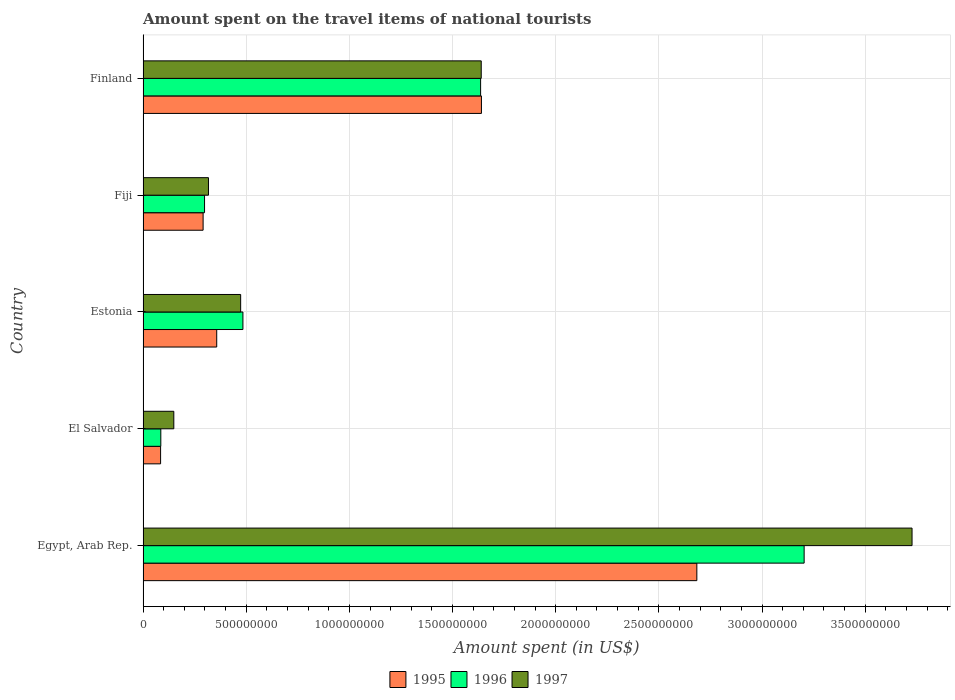How many different coloured bars are there?
Offer a very short reply. 3. How many groups of bars are there?
Offer a terse response. 5. Are the number of bars per tick equal to the number of legend labels?
Keep it short and to the point. Yes. Are the number of bars on each tick of the Y-axis equal?
Ensure brevity in your answer.  Yes. How many bars are there on the 3rd tick from the bottom?
Offer a very short reply. 3. What is the amount spent on the travel items of national tourists in 1997 in Estonia?
Your response must be concise. 4.73e+08. Across all countries, what is the maximum amount spent on the travel items of national tourists in 1995?
Your answer should be compact. 2.68e+09. Across all countries, what is the minimum amount spent on the travel items of national tourists in 1995?
Your answer should be very brief. 8.50e+07. In which country was the amount spent on the travel items of national tourists in 1995 maximum?
Provide a short and direct response. Egypt, Arab Rep. In which country was the amount spent on the travel items of national tourists in 1997 minimum?
Provide a short and direct response. El Salvador. What is the total amount spent on the travel items of national tourists in 1996 in the graph?
Your response must be concise. 5.71e+09. What is the difference between the amount spent on the travel items of national tourists in 1997 in El Salvador and that in Estonia?
Your answer should be compact. -3.24e+08. What is the difference between the amount spent on the travel items of national tourists in 1997 in El Salvador and the amount spent on the travel items of national tourists in 1995 in Estonia?
Offer a terse response. -2.08e+08. What is the average amount spent on the travel items of national tourists in 1995 per country?
Keep it short and to the point. 1.01e+09. What is the difference between the amount spent on the travel items of national tourists in 1996 and amount spent on the travel items of national tourists in 1997 in Estonia?
Make the answer very short. 1.10e+07. In how many countries, is the amount spent on the travel items of national tourists in 1996 greater than 3800000000 US$?
Give a very brief answer. 0. What is the ratio of the amount spent on the travel items of national tourists in 1997 in El Salvador to that in Finland?
Make the answer very short. 0.09. Is the difference between the amount spent on the travel items of national tourists in 1996 in El Salvador and Finland greater than the difference between the amount spent on the travel items of national tourists in 1997 in El Salvador and Finland?
Your answer should be compact. No. What is the difference between the highest and the second highest amount spent on the travel items of national tourists in 1995?
Your answer should be very brief. 1.04e+09. What is the difference between the highest and the lowest amount spent on the travel items of national tourists in 1995?
Your answer should be very brief. 2.60e+09. In how many countries, is the amount spent on the travel items of national tourists in 1997 greater than the average amount spent on the travel items of national tourists in 1997 taken over all countries?
Offer a terse response. 2. Is the sum of the amount spent on the travel items of national tourists in 1996 in El Salvador and Finland greater than the maximum amount spent on the travel items of national tourists in 1997 across all countries?
Keep it short and to the point. No. What does the 1st bar from the top in Estonia represents?
Your response must be concise. 1997. Is it the case that in every country, the sum of the amount spent on the travel items of national tourists in 1996 and amount spent on the travel items of national tourists in 1995 is greater than the amount spent on the travel items of national tourists in 1997?
Offer a terse response. Yes. How many bars are there?
Provide a short and direct response. 15. Are all the bars in the graph horizontal?
Your answer should be compact. Yes. How many countries are there in the graph?
Your response must be concise. 5. What is the difference between two consecutive major ticks on the X-axis?
Your answer should be compact. 5.00e+08. Are the values on the major ticks of X-axis written in scientific E-notation?
Your response must be concise. No. Does the graph contain any zero values?
Your response must be concise. No. How many legend labels are there?
Offer a very short reply. 3. What is the title of the graph?
Your answer should be very brief. Amount spent on the travel items of national tourists. Does "1975" appear as one of the legend labels in the graph?
Your answer should be compact. No. What is the label or title of the X-axis?
Offer a very short reply. Amount spent (in US$). What is the Amount spent (in US$) of 1995 in Egypt, Arab Rep.?
Provide a succinct answer. 2.68e+09. What is the Amount spent (in US$) of 1996 in Egypt, Arab Rep.?
Your answer should be very brief. 3.20e+09. What is the Amount spent (in US$) in 1997 in Egypt, Arab Rep.?
Your answer should be compact. 3.73e+09. What is the Amount spent (in US$) in 1995 in El Salvador?
Provide a short and direct response. 8.50e+07. What is the Amount spent (in US$) of 1996 in El Salvador?
Provide a short and direct response. 8.60e+07. What is the Amount spent (in US$) in 1997 in El Salvador?
Offer a terse response. 1.49e+08. What is the Amount spent (in US$) in 1995 in Estonia?
Give a very brief answer. 3.57e+08. What is the Amount spent (in US$) of 1996 in Estonia?
Keep it short and to the point. 4.84e+08. What is the Amount spent (in US$) in 1997 in Estonia?
Your answer should be very brief. 4.73e+08. What is the Amount spent (in US$) of 1995 in Fiji?
Your answer should be very brief. 2.91e+08. What is the Amount spent (in US$) of 1996 in Fiji?
Keep it short and to the point. 2.98e+08. What is the Amount spent (in US$) of 1997 in Fiji?
Your answer should be compact. 3.17e+08. What is the Amount spent (in US$) of 1995 in Finland?
Your response must be concise. 1.64e+09. What is the Amount spent (in US$) in 1996 in Finland?
Give a very brief answer. 1.64e+09. What is the Amount spent (in US$) of 1997 in Finland?
Provide a short and direct response. 1.64e+09. Across all countries, what is the maximum Amount spent (in US$) in 1995?
Your answer should be very brief. 2.68e+09. Across all countries, what is the maximum Amount spent (in US$) of 1996?
Offer a terse response. 3.20e+09. Across all countries, what is the maximum Amount spent (in US$) in 1997?
Offer a terse response. 3.73e+09. Across all countries, what is the minimum Amount spent (in US$) of 1995?
Provide a succinct answer. 8.50e+07. Across all countries, what is the minimum Amount spent (in US$) of 1996?
Ensure brevity in your answer.  8.60e+07. Across all countries, what is the minimum Amount spent (in US$) of 1997?
Your answer should be compact. 1.49e+08. What is the total Amount spent (in US$) in 1995 in the graph?
Ensure brevity in your answer.  5.06e+09. What is the total Amount spent (in US$) in 1996 in the graph?
Offer a very short reply. 5.71e+09. What is the total Amount spent (in US$) in 1997 in the graph?
Offer a very short reply. 6.30e+09. What is the difference between the Amount spent (in US$) of 1995 in Egypt, Arab Rep. and that in El Salvador?
Give a very brief answer. 2.60e+09. What is the difference between the Amount spent (in US$) of 1996 in Egypt, Arab Rep. and that in El Salvador?
Offer a very short reply. 3.12e+09. What is the difference between the Amount spent (in US$) in 1997 in Egypt, Arab Rep. and that in El Salvador?
Your answer should be compact. 3.58e+09. What is the difference between the Amount spent (in US$) of 1995 in Egypt, Arab Rep. and that in Estonia?
Your answer should be compact. 2.33e+09. What is the difference between the Amount spent (in US$) of 1996 in Egypt, Arab Rep. and that in Estonia?
Your answer should be compact. 2.72e+09. What is the difference between the Amount spent (in US$) of 1997 in Egypt, Arab Rep. and that in Estonia?
Offer a very short reply. 3.25e+09. What is the difference between the Amount spent (in US$) of 1995 in Egypt, Arab Rep. and that in Fiji?
Offer a terse response. 2.39e+09. What is the difference between the Amount spent (in US$) in 1996 in Egypt, Arab Rep. and that in Fiji?
Provide a short and direct response. 2.91e+09. What is the difference between the Amount spent (in US$) in 1997 in Egypt, Arab Rep. and that in Fiji?
Provide a short and direct response. 3.41e+09. What is the difference between the Amount spent (in US$) of 1995 in Egypt, Arab Rep. and that in Finland?
Offer a very short reply. 1.04e+09. What is the difference between the Amount spent (in US$) of 1996 in Egypt, Arab Rep. and that in Finland?
Keep it short and to the point. 1.57e+09. What is the difference between the Amount spent (in US$) of 1997 in Egypt, Arab Rep. and that in Finland?
Your answer should be very brief. 2.09e+09. What is the difference between the Amount spent (in US$) in 1995 in El Salvador and that in Estonia?
Ensure brevity in your answer.  -2.72e+08. What is the difference between the Amount spent (in US$) of 1996 in El Salvador and that in Estonia?
Offer a terse response. -3.98e+08. What is the difference between the Amount spent (in US$) of 1997 in El Salvador and that in Estonia?
Give a very brief answer. -3.24e+08. What is the difference between the Amount spent (in US$) in 1995 in El Salvador and that in Fiji?
Your response must be concise. -2.06e+08. What is the difference between the Amount spent (in US$) in 1996 in El Salvador and that in Fiji?
Your answer should be compact. -2.12e+08. What is the difference between the Amount spent (in US$) in 1997 in El Salvador and that in Fiji?
Ensure brevity in your answer.  -1.68e+08. What is the difference between the Amount spent (in US$) of 1995 in El Salvador and that in Finland?
Ensure brevity in your answer.  -1.56e+09. What is the difference between the Amount spent (in US$) of 1996 in El Salvador and that in Finland?
Provide a succinct answer. -1.55e+09. What is the difference between the Amount spent (in US$) in 1997 in El Salvador and that in Finland?
Give a very brief answer. -1.49e+09. What is the difference between the Amount spent (in US$) in 1995 in Estonia and that in Fiji?
Ensure brevity in your answer.  6.60e+07. What is the difference between the Amount spent (in US$) of 1996 in Estonia and that in Fiji?
Provide a succinct answer. 1.86e+08. What is the difference between the Amount spent (in US$) in 1997 in Estonia and that in Fiji?
Your answer should be compact. 1.56e+08. What is the difference between the Amount spent (in US$) in 1995 in Estonia and that in Finland?
Ensure brevity in your answer.  -1.28e+09. What is the difference between the Amount spent (in US$) in 1996 in Estonia and that in Finland?
Provide a short and direct response. -1.15e+09. What is the difference between the Amount spent (in US$) in 1997 in Estonia and that in Finland?
Provide a short and direct response. -1.17e+09. What is the difference between the Amount spent (in US$) of 1995 in Fiji and that in Finland?
Your response must be concise. -1.35e+09. What is the difference between the Amount spent (in US$) of 1996 in Fiji and that in Finland?
Your response must be concise. -1.34e+09. What is the difference between the Amount spent (in US$) in 1997 in Fiji and that in Finland?
Keep it short and to the point. -1.32e+09. What is the difference between the Amount spent (in US$) in 1995 in Egypt, Arab Rep. and the Amount spent (in US$) in 1996 in El Salvador?
Keep it short and to the point. 2.60e+09. What is the difference between the Amount spent (in US$) in 1995 in Egypt, Arab Rep. and the Amount spent (in US$) in 1997 in El Salvador?
Ensure brevity in your answer.  2.54e+09. What is the difference between the Amount spent (in US$) of 1996 in Egypt, Arab Rep. and the Amount spent (in US$) of 1997 in El Salvador?
Provide a succinct answer. 3.06e+09. What is the difference between the Amount spent (in US$) in 1995 in Egypt, Arab Rep. and the Amount spent (in US$) in 1996 in Estonia?
Provide a succinct answer. 2.20e+09. What is the difference between the Amount spent (in US$) in 1995 in Egypt, Arab Rep. and the Amount spent (in US$) in 1997 in Estonia?
Your response must be concise. 2.21e+09. What is the difference between the Amount spent (in US$) in 1996 in Egypt, Arab Rep. and the Amount spent (in US$) in 1997 in Estonia?
Provide a succinct answer. 2.73e+09. What is the difference between the Amount spent (in US$) of 1995 in Egypt, Arab Rep. and the Amount spent (in US$) of 1996 in Fiji?
Ensure brevity in your answer.  2.39e+09. What is the difference between the Amount spent (in US$) of 1995 in Egypt, Arab Rep. and the Amount spent (in US$) of 1997 in Fiji?
Offer a terse response. 2.37e+09. What is the difference between the Amount spent (in US$) in 1996 in Egypt, Arab Rep. and the Amount spent (in US$) in 1997 in Fiji?
Your response must be concise. 2.89e+09. What is the difference between the Amount spent (in US$) in 1995 in Egypt, Arab Rep. and the Amount spent (in US$) in 1996 in Finland?
Your answer should be compact. 1.05e+09. What is the difference between the Amount spent (in US$) in 1995 in Egypt, Arab Rep. and the Amount spent (in US$) in 1997 in Finland?
Ensure brevity in your answer.  1.04e+09. What is the difference between the Amount spent (in US$) of 1996 in Egypt, Arab Rep. and the Amount spent (in US$) of 1997 in Finland?
Offer a very short reply. 1.56e+09. What is the difference between the Amount spent (in US$) of 1995 in El Salvador and the Amount spent (in US$) of 1996 in Estonia?
Offer a very short reply. -3.99e+08. What is the difference between the Amount spent (in US$) in 1995 in El Salvador and the Amount spent (in US$) in 1997 in Estonia?
Your answer should be very brief. -3.88e+08. What is the difference between the Amount spent (in US$) of 1996 in El Salvador and the Amount spent (in US$) of 1997 in Estonia?
Provide a succinct answer. -3.87e+08. What is the difference between the Amount spent (in US$) of 1995 in El Salvador and the Amount spent (in US$) of 1996 in Fiji?
Give a very brief answer. -2.13e+08. What is the difference between the Amount spent (in US$) of 1995 in El Salvador and the Amount spent (in US$) of 1997 in Fiji?
Give a very brief answer. -2.32e+08. What is the difference between the Amount spent (in US$) of 1996 in El Salvador and the Amount spent (in US$) of 1997 in Fiji?
Provide a succinct answer. -2.31e+08. What is the difference between the Amount spent (in US$) in 1995 in El Salvador and the Amount spent (in US$) in 1996 in Finland?
Offer a terse response. -1.55e+09. What is the difference between the Amount spent (in US$) in 1995 in El Salvador and the Amount spent (in US$) in 1997 in Finland?
Offer a terse response. -1.55e+09. What is the difference between the Amount spent (in US$) of 1996 in El Salvador and the Amount spent (in US$) of 1997 in Finland?
Your response must be concise. -1.55e+09. What is the difference between the Amount spent (in US$) of 1995 in Estonia and the Amount spent (in US$) of 1996 in Fiji?
Your answer should be very brief. 5.90e+07. What is the difference between the Amount spent (in US$) in 1995 in Estonia and the Amount spent (in US$) in 1997 in Fiji?
Provide a short and direct response. 4.00e+07. What is the difference between the Amount spent (in US$) of 1996 in Estonia and the Amount spent (in US$) of 1997 in Fiji?
Your answer should be very brief. 1.67e+08. What is the difference between the Amount spent (in US$) in 1995 in Estonia and the Amount spent (in US$) in 1996 in Finland?
Provide a short and direct response. -1.28e+09. What is the difference between the Amount spent (in US$) of 1995 in Estonia and the Amount spent (in US$) of 1997 in Finland?
Provide a short and direct response. -1.28e+09. What is the difference between the Amount spent (in US$) in 1996 in Estonia and the Amount spent (in US$) in 1997 in Finland?
Ensure brevity in your answer.  -1.16e+09. What is the difference between the Amount spent (in US$) in 1995 in Fiji and the Amount spent (in US$) in 1996 in Finland?
Ensure brevity in your answer.  -1.34e+09. What is the difference between the Amount spent (in US$) in 1995 in Fiji and the Amount spent (in US$) in 1997 in Finland?
Give a very brief answer. -1.35e+09. What is the difference between the Amount spent (in US$) of 1996 in Fiji and the Amount spent (in US$) of 1997 in Finland?
Make the answer very short. -1.34e+09. What is the average Amount spent (in US$) of 1995 per country?
Provide a succinct answer. 1.01e+09. What is the average Amount spent (in US$) in 1996 per country?
Your response must be concise. 1.14e+09. What is the average Amount spent (in US$) of 1997 per country?
Your response must be concise. 1.26e+09. What is the difference between the Amount spent (in US$) in 1995 and Amount spent (in US$) in 1996 in Egypt, Arab Rep.?
Your answer should be very brief. -5.20e+08. What is the difference between the Amount spent (in US$) of 1995 and Amount spent (in US$) of 1997 in Egypt, Arab Rep.?
Keep it short and to the point. -1.04e+09. What is the difference between the Amount spent (in US$) in 1996 and Amount spent (in US$) in 1997 in Egypt, Arab Rep.?
Your answer should be compact. -5.23e+08. What is the difference between the Amount spent (in US$) of 1995 and Amount spent (in US$) of 1997 in El Salvador?
Your answer should be compact. -6.40e+07. What is the difference between the Amount spent (in US$) in 1996 and Amount spent (in US$) in 1997 in El Salvador?
Provide a short and direct response. -6.30e+07. What is the difference between the Amount spent (in US$) of 1995 and Amount spent (in US$) of 1996 in Estonia?
Provide a succinct answer. -1.27e+08. What is the difference between the Amount spent (in US$) of 1995 and Amount spent (in US$) of 1997 in Estonia?
Provide a succinct answer. -1.16e+08. What is the difference between the Amount spent (in US$) in 1996 and Amount spent (in US$) in 1997 in Estonia?
Provide a short and direct response. 1.10e+07. What is the difference between the Amount spent (in US$) in 1995 and Amount spent (in US$) in 1996 in Fiji?
Make the answer very short. -7.00e+06. What is the difference between the Amount spent (in US$) in 1995 and Amount spent (in US$) in 1997 in Fiji?
Offer a terse response. -2.60e+07. What is the difference between the Amount spent (in US$) of 1996 and Amount spent (in US$) of 1997 in Fiji?
Keep it short and to the point. -1.90e+07. What is the ratio of the Amount spent (in US$) in 1995 in Egypt, Arab Rep. to that in El Salvador?
Keep it short and to the point. 31.58. What is the ratio of the Amount spent (in US$) in 1996 in Egypt, Arab Rep. to that in El Salvador?
Offer a very short reply. 37.26. What is the ratio of the Amount spent (in US$) in 1997 in Egypt, Arab Rep. to that in El Salvador?
Give a very brief answer. 25.01. What is the ratio of the Amount spent (in US$) of 1995 in Egypt, Arab Rep. to that in Estonia?
Offer a terse response. 7.52. What is the ratio of the Amount spent (in US$) of 1996 in Egypt, Arab Rep. to that in Estonia?
Make the answer very short. 6.62. What is the ratio of the Amount spent (in US$) of 1997 in Egypt, Arab Rep. to that in Estonia?
Provide a short and direct response. 7.88. What is the ratio of the Amount spent (in US$) in 1995 in Egypt, Arab Rep. to that in Fiji?
Your answer should be very brief. 9.22. What is the ratio of the Amount spent (in US$) in 1996 in Egypt, Arab Rep. to that in Fiji?
Offer a terse response. 10.75. What is the ratio of the Amount spent (in US$) in 1997 in Egypt, Arab Rep. to that in Fiji?
Your response must be concise. 11.76. What is the ratio of the Amount spent (in US$) of 1995 in Egypt, Arab Rep. to that in Finland?
Offer a very short reply. 1.64. What is the ratio of the Amount spent (in US$) in 1996 in Egypt, Arab Rep. to that in Finland?
Provide a short and direct response. 1.96. What is the ratio of the Amount spent (in US$) in 1997 in Egypt, Arab Rep. to that in Finland?
Make the answer very short. 2.27. What is the ratio of the Amount spent (in US$) in 1995 in El Salvador to that in Estonia?
Your response must be concise. 0.24. What is the ratio of the Amount spent (in US$) in 1996 in El Salvador to that in Estonia?
Provide a short and direct response. 0.18. What is the ratio of the Amount spent (in US$) of 1997 in El Salvador to that in Estonia?
Keep it short and to the point. 0.32. What is the ratio of the Amount spent (in US$) of 1995 in El Salvador to that in Fiji?
Your response must be concise. 0.29. What is the ratio of the Amount spent (in US$) of 1996 in El Salvador to that in Fiji?
Your answer should be compact. 0.29. What is the ratio of the Amount spent (in US$) in 1997 in El Salvador to that in Fiji?
Offer a terse response. 0.47. What is the ratio of the Amount spent (in US$) in 1995 in El Salvador to that in Finland?
Give a very brief answer. 0.05. What is the ratio of the Amount spent (in US$) of 1996 in El Salvador to that in Finland?
Make the answer very short. 0.05. What is the ratio of the Amount spent (in US$) of 1997 in El Salvador to that in Finland?
Ensure brevity in your answer.  0.09. What is the ratio of the Amount spent (in US$) in 1995 in Estonia to that in Fiji?
Your answer should be compact. 1.23. What is the ratio of the Amount spent (in US$) in 1996 in Estonia to that in Fiji?
Your answer should be very brief. 1.62. What is the ratio of the Amount spent (in US$) in 1997 in Estonia to that in Fiji?
Offer a terse response. 1.49. What is the ratio of the Amount spent (in US$) in 1995 in Estonia to that in Finland?
Ensure brevity in your answer.  0.22. What is the ratio of the Amount spent (in US$) in 1996 in Estonia to that in Finland?
Offer a terse response. 0.3. What is the ratio of the Amount spent (in US$) of 1997 in Estonia to that in Finland?
Keep it short and to the point. 0.29. What is the ratio of the Amount spent (in US$) in 1995 in Fiji to that in Finland?
Provide a short and direct response. 0.18. What is the ratio of the Amount spent (in US$) in 1996 in Fiji to that in Finland?
Provide a short and direct response. 0.18. What is the ratio of the Amount spent (in US$) of 1997 in Fiji to that in Finland?
Provide a short and direct response. 0.19. What is the difference between the highest and the second highest Amount spent (in US$) in 1995?
Ensure brevity in your answer.  1.04e+09. What is the difference between the highest and the second highest Amount spent (in US$) in 1996?
Your answer should be very brief. 1.57e+09. What is the difference between the highest and the second highest Amount spent (in US$) in 1997?
Your answer should be very brief. 2.09e+09. What is the difference between the highest and the lowest Amount spent (in US$) in 1995?
Ensure brevity in your answer.  2.60e+09. What is the difference between the highest and the lowest Amount spent (in US$) of 1996?
Keep it short and to the point. 3.12e+09. What is the difference between the highest and the lowest Amount spent (in US$) in 1997?
Provide a short and direct response. 3.58e+09. 